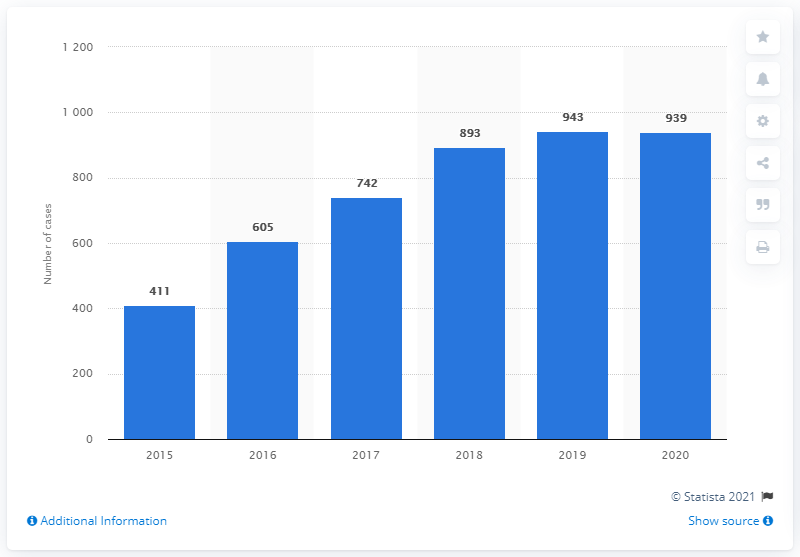Outline some significant characteristics in this image. Between 2015 and 2019, a total of 411 cases of femicide were reported. According to official statistics, in Mexico, 939 cases of femicide were reported from January to December 2020. 